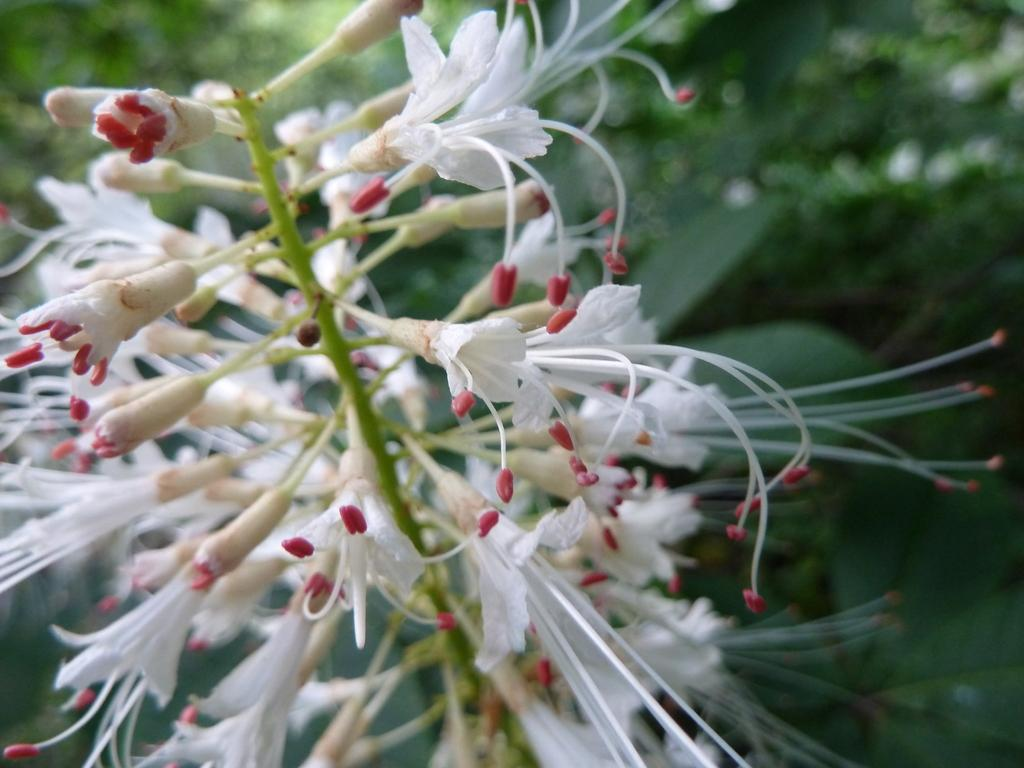What type of plant is in the image? There is a white grevillea in the image. Can you describe the background of the image? The background of the image is blurred. How does the brain of the white grevillea appear in the image? There is no brain present in the image, as it features a white grevillea plant. 